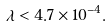<formula> <loc_0><loc_0><loc_500><loc_500>\lambda < 4 . 7 \times 1 0 ^ { - 4 } .</formula> 